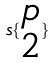Convert formula to latex. <formula><loc_0><loc_0><loc_500><loc_500>s \{ \begin{matrix} p \\ 2 \end{matrix} \}</formula> 